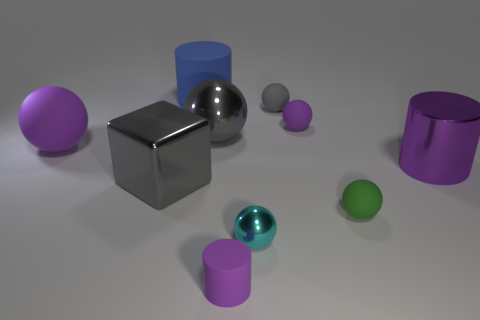Is the number of big purple rubber objects greater than the number of large green shiny cylinders?
Keep it short and to the point. Yes. Are there any other things of the same color as the small cylinder?
Keep it short and to the point. Yes. The purple thing that is the same material as the block is what shape?
Make the answer very short. Cylinder. What material is the large gray thing that is in front of the purple thing to the left of the large matte cylinder made of?
Your answer should be compact. Metal. There is a large gray metal object in front of the purple metal cylinder; is it the same shape as the gray rubber thing?
Your answer should be very brief. No. Is the number of rubber objects in front of the purple metal object greater than the number of big gray metallic cubes?
Give a very brief answer. Yes. The large thing that is the same color as the shiny cube is what shape?
Offer a very short reply. Sphere. How many cylinders are large purple matte objects or tiny objects?
Give a very brief answer. 1. There is a small sphere that is to the right of the tiny purple rubber thing behind the big purple sphere; what color is it?
Your answer should be compact. Green. There is a big metallic sphere; is it the same color as the small object behind the small purple matte ball?
Offer a terse response. Yes. 